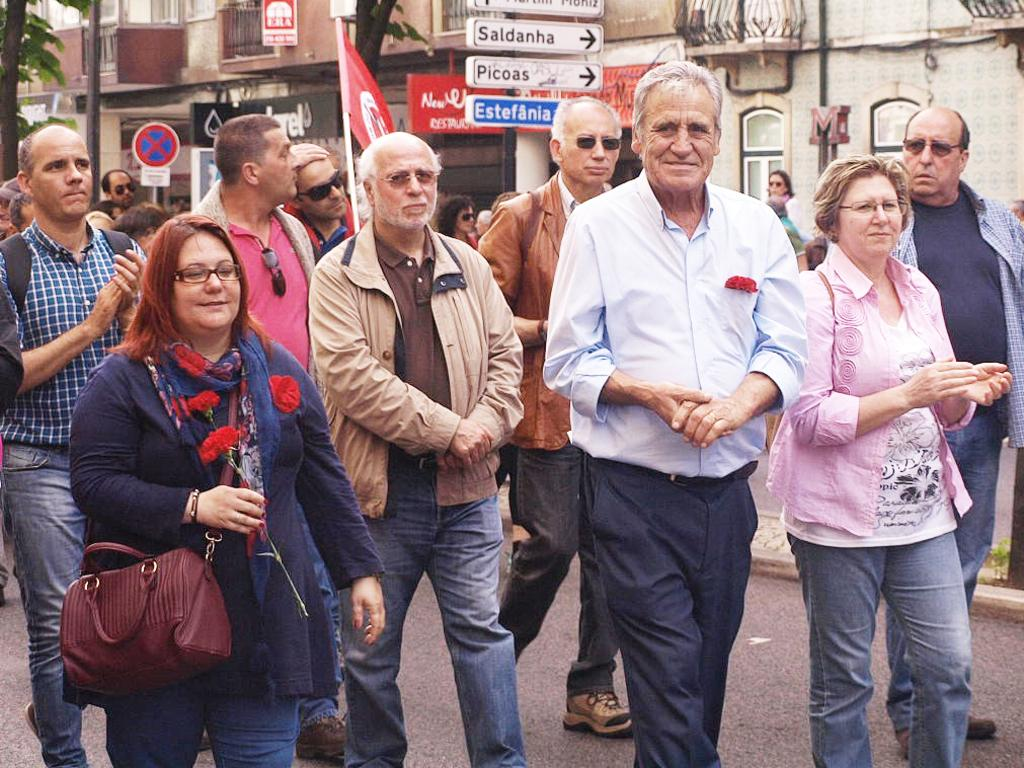What are the people in the image doing? There is a group of people walking on the road in the image. What type of structure can be seen in the image? There is a building in the image. What natural element is present in the image? There is a tree in the image. What additional object can be seen in the image? There is a flag in the image. What type of art can be seen on the flag in the image? There is no art present on the flag in the image; it is a solid color or pattern. 